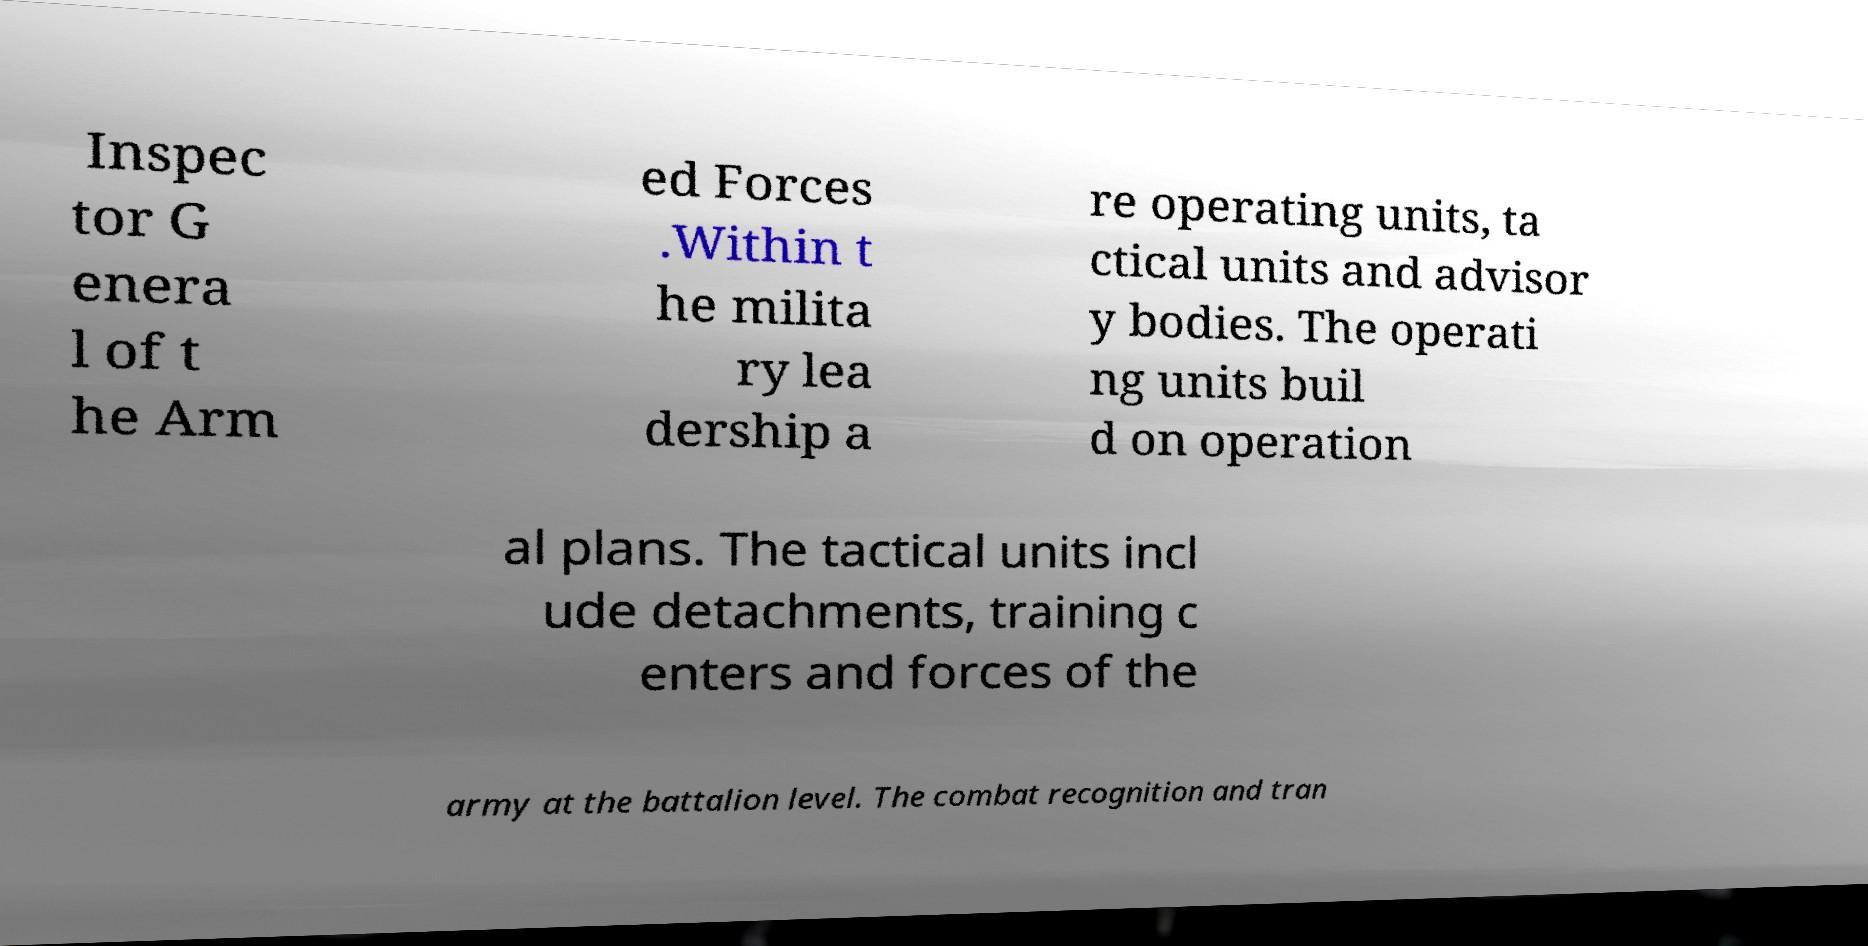Can you accurately transcribe the text from the provided image for me? Inspec tor G enera l of t he Arm ed Forces .Within t he milita ry lea dership a re operating units, ta ctical units and advisor y bodies. The operati ng units buil d on operation al plans. The tactical units incl ude detachments, training c enters and forces of the army at the battalion level. The combat recognition and tran 